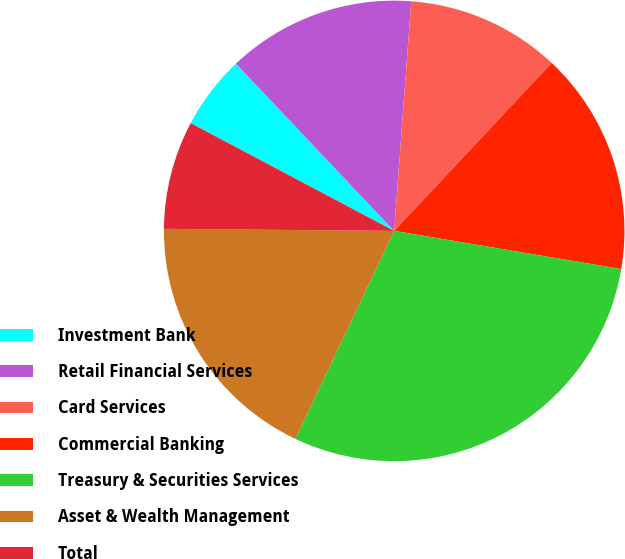Convert chart. <chart><loc_0><loc_0><loc_500><loc_500><pie_chart><fcel>Investment Bank<fcel>Retail Financial Services<fcel>Card Services<fcel>Commercial Banking<fcel>Treasury & Securities Services<fcel>Asset & Wealth Management<fcel>Total<nl><fcel>5.19%<fcel>13.24%<fcel>10.81%<fcel>15.66%<fcel>29.41%<fcel>18.08%<fcel>7.61%<nl></chart> 